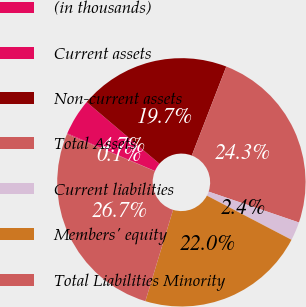<chart> <loc_0><loc_0><loc_500><loc_500><pie_chart><fcel>(in thousands)<fcel>Current assets<fcel>Non-current assets<fcel>Total Assets<fcel>Current liabilities<fcel>Members' equity<fcel>Total Liabilities Minority<nl><fcel>0.1%<fcel>4.73%<fcel>19.71%<fcel>24.35%<fcel>2.42%<fcel>22.03%<fcel>26.67%<nl></chart> 